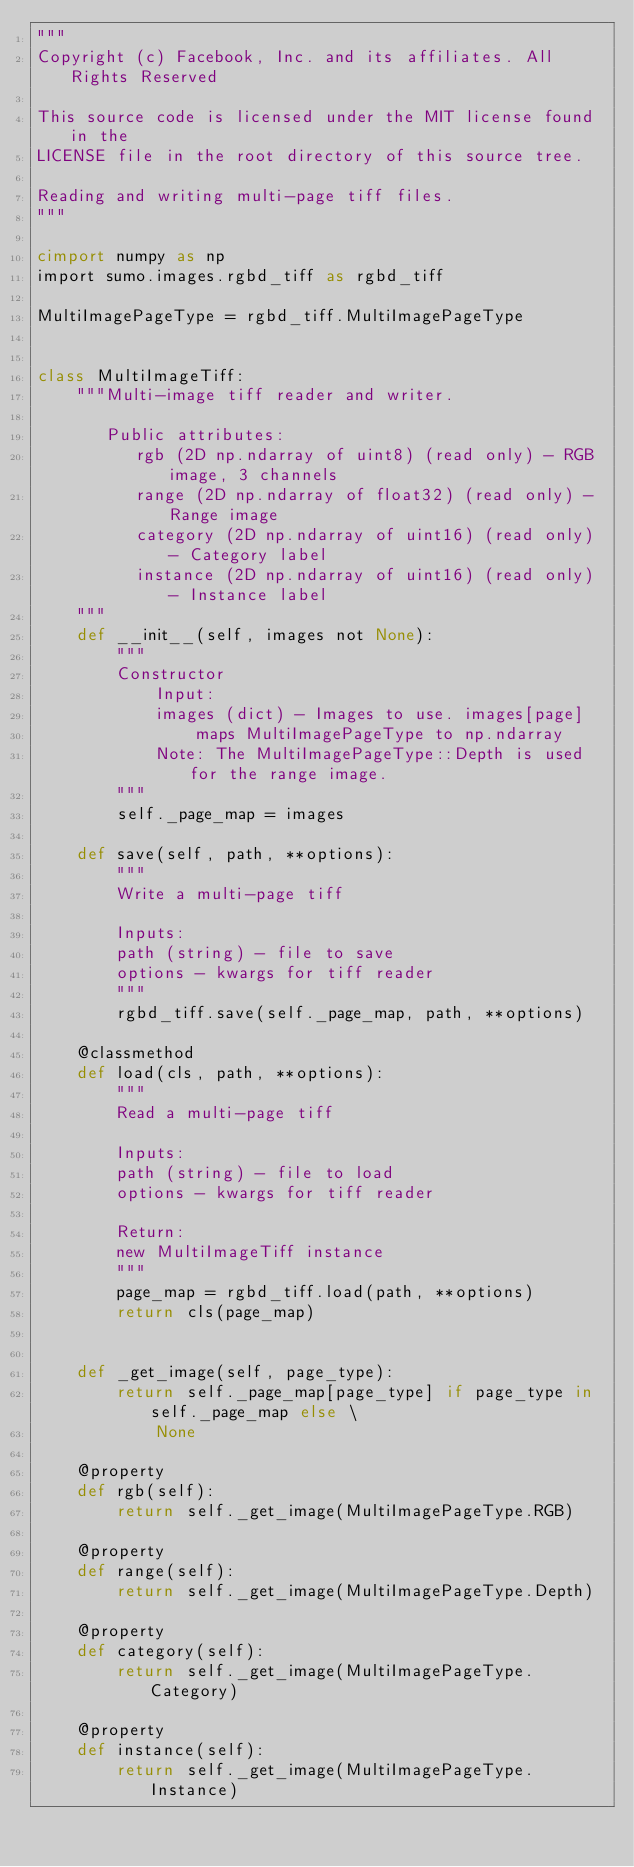Convert code to text. <code><loc_0><loc_0><loc_500><loc_500><_Cython_>"""
Copyright (c) Facebook, Inc. and its affiliates. All Rights Reserved

This source code is licensed under the MIT license found in the
LICENSE file in the root directory of this source tree.

Reading and writing multi-page tiff files.
"""

cimport numpy as np
import sumo.images.rgbd_tiff as rgbd_tiff

MultiImagePageType = rgbd_tiff.MultiImagePageType


class MultiImageTiff:
    """Multi-image tiff reader and writer.

       Public attributes:
          rgb (2D np.ndarray of uint8) (read only) - RGB image, 3 channels
          range (2D np.ndarray of float32) (read only) - Range image
          category (2D np.ndarray of uint16) (read only) - Category label
          instance (2D np.ndarray of uint16) (read only) - Instance label
    """
    def __init__(self, images not None):
        """
        Constructor
            Input:
            images (dict) - Images to use. images[page]
                maps MultiImagePageType to np.ndarray
            Note: The MultiImagePageType::Depth is used for the range image.
        """
        self._page_map = images

    def save(self, path, **options):
        """
        Write a multi-page tiff

        Inputs:
        path (string) - file to save
        options - kwargs for tiff reader
        """
        rgbd_tiff.save(self._page_map, path, **options)

    @classmethod
    def load(cls, path, **options):
        """
        Read a multi-page tiff

        Inputs:
        path (string) - file to load
        options - kwargs for tiff reader

        Return:
        new MultiImageTiff instance
        """
        page_map = rgbd_tiff.load(path, **options)
        return cls(page_map)


    def _get_image(self, page_type):
        return self._page_map[page_type] if page_type in self._page_map else \
            None

    @property
    def rgb(self):
        return self._get_image(MultiImagePageType.RGB)

    @property
    def range(self):
        return self._get_image(MultiImagePageType.Depth)

    @property
    def category(self):
        return self._get_image(MultiImagePageType.Category)

    @property
    def instance(self):
        return self._get_image(MultiImagePageType.Instance)
</code> 